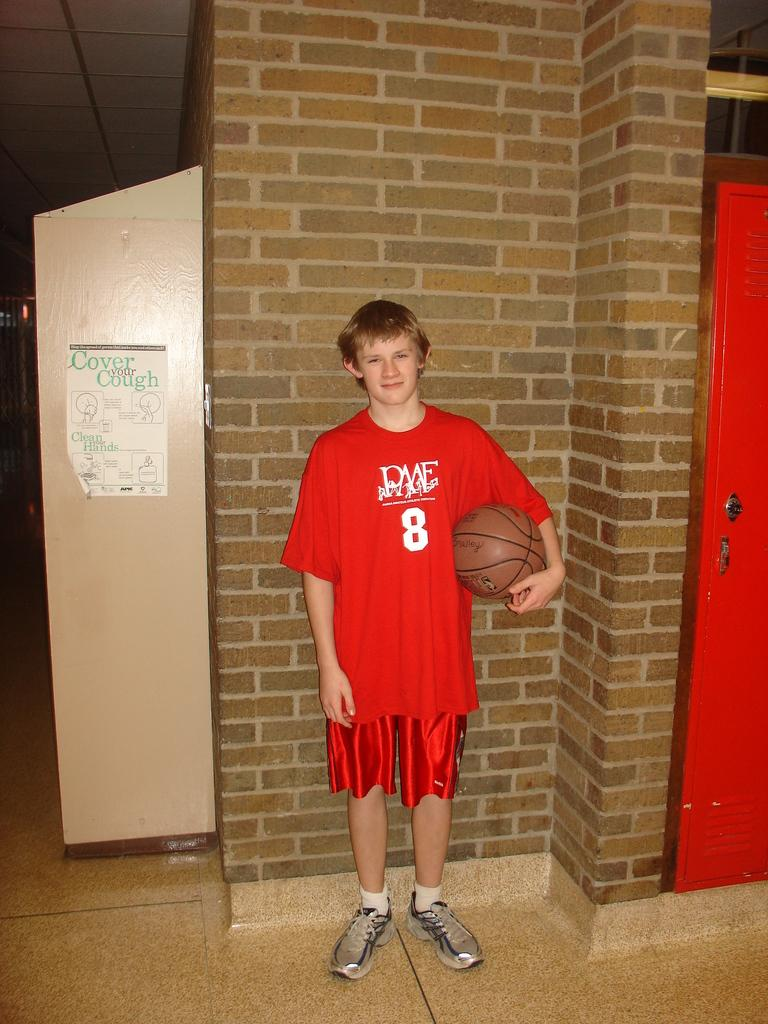Who is the main subject in the center of the image? There is a man in the center of the image. What is the man wearing? The man is wearing a red dress. What is the man holding in the image? The man is holding a ball. What can be seen on the right side of the image? There is a door on the right side of the image. What is visible in the background of the image? There is a wall in the background of the image. What object is located on the left side of the image? There is an object on the left side of the image. How many women are present in the image? There are no women present in the image; it features a man wearing a red dress. What type of wound can be seen on the man's arm in the image? There is no wound visible on the man's arm in the image. 